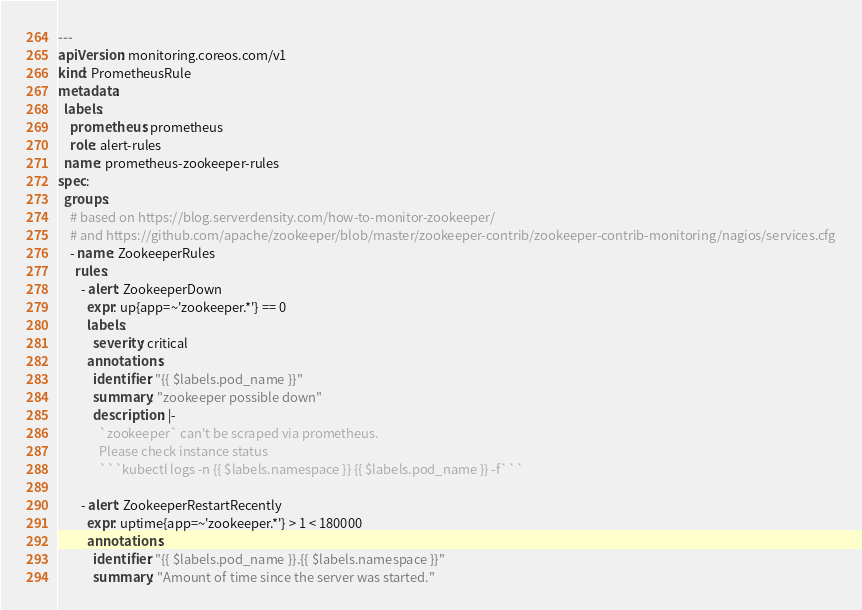Convert code to text. <code><loc_0><loc_0><loc_500><loc_500><_YAML_>---
apiVersion: monitoring.coreos.com/v1
kind: PrometheusRule
metadata:
  labels:
    prometheus: prometheus
    role: alert-rules
  name: prometheus-zookeeper-rules
spec:
  groups:
    # based on https://blog.serverdensity.com/how-to-monitor-zookeeper/
    # and https://github.com/apache/zookeeper/blob/master/zookeeper-contrib/zookeeper-contrib-monitoring/nagios/services.cfg
    - name: ZookeeperRules
      rules:
        - alert: ZookeeperDown
          expr: up{app=~'zookeeper.*'} == 0
          labels:
            severity: critical
          annotations:
            identifier: "{{ $labels.pod_name }}"
            summary: "zookeeper possible down"
            description: |-
              `zookeeper` can't be scraped via prometheus.
              Please check instance status
              ```kubectl logs -n {{ $labels.namespace }} {{ $labels.pod_name }} -f```

        - alert: ZookeeperRestartRecently
          expr: uptime{app=~'zookeeper.*'} > 1 < 180000
          annotations:
            identifier: "{{ $labels.pod_name }}.{{ $labels.namespace }}"
            summary: "Amount of time since the server was started."</code> 